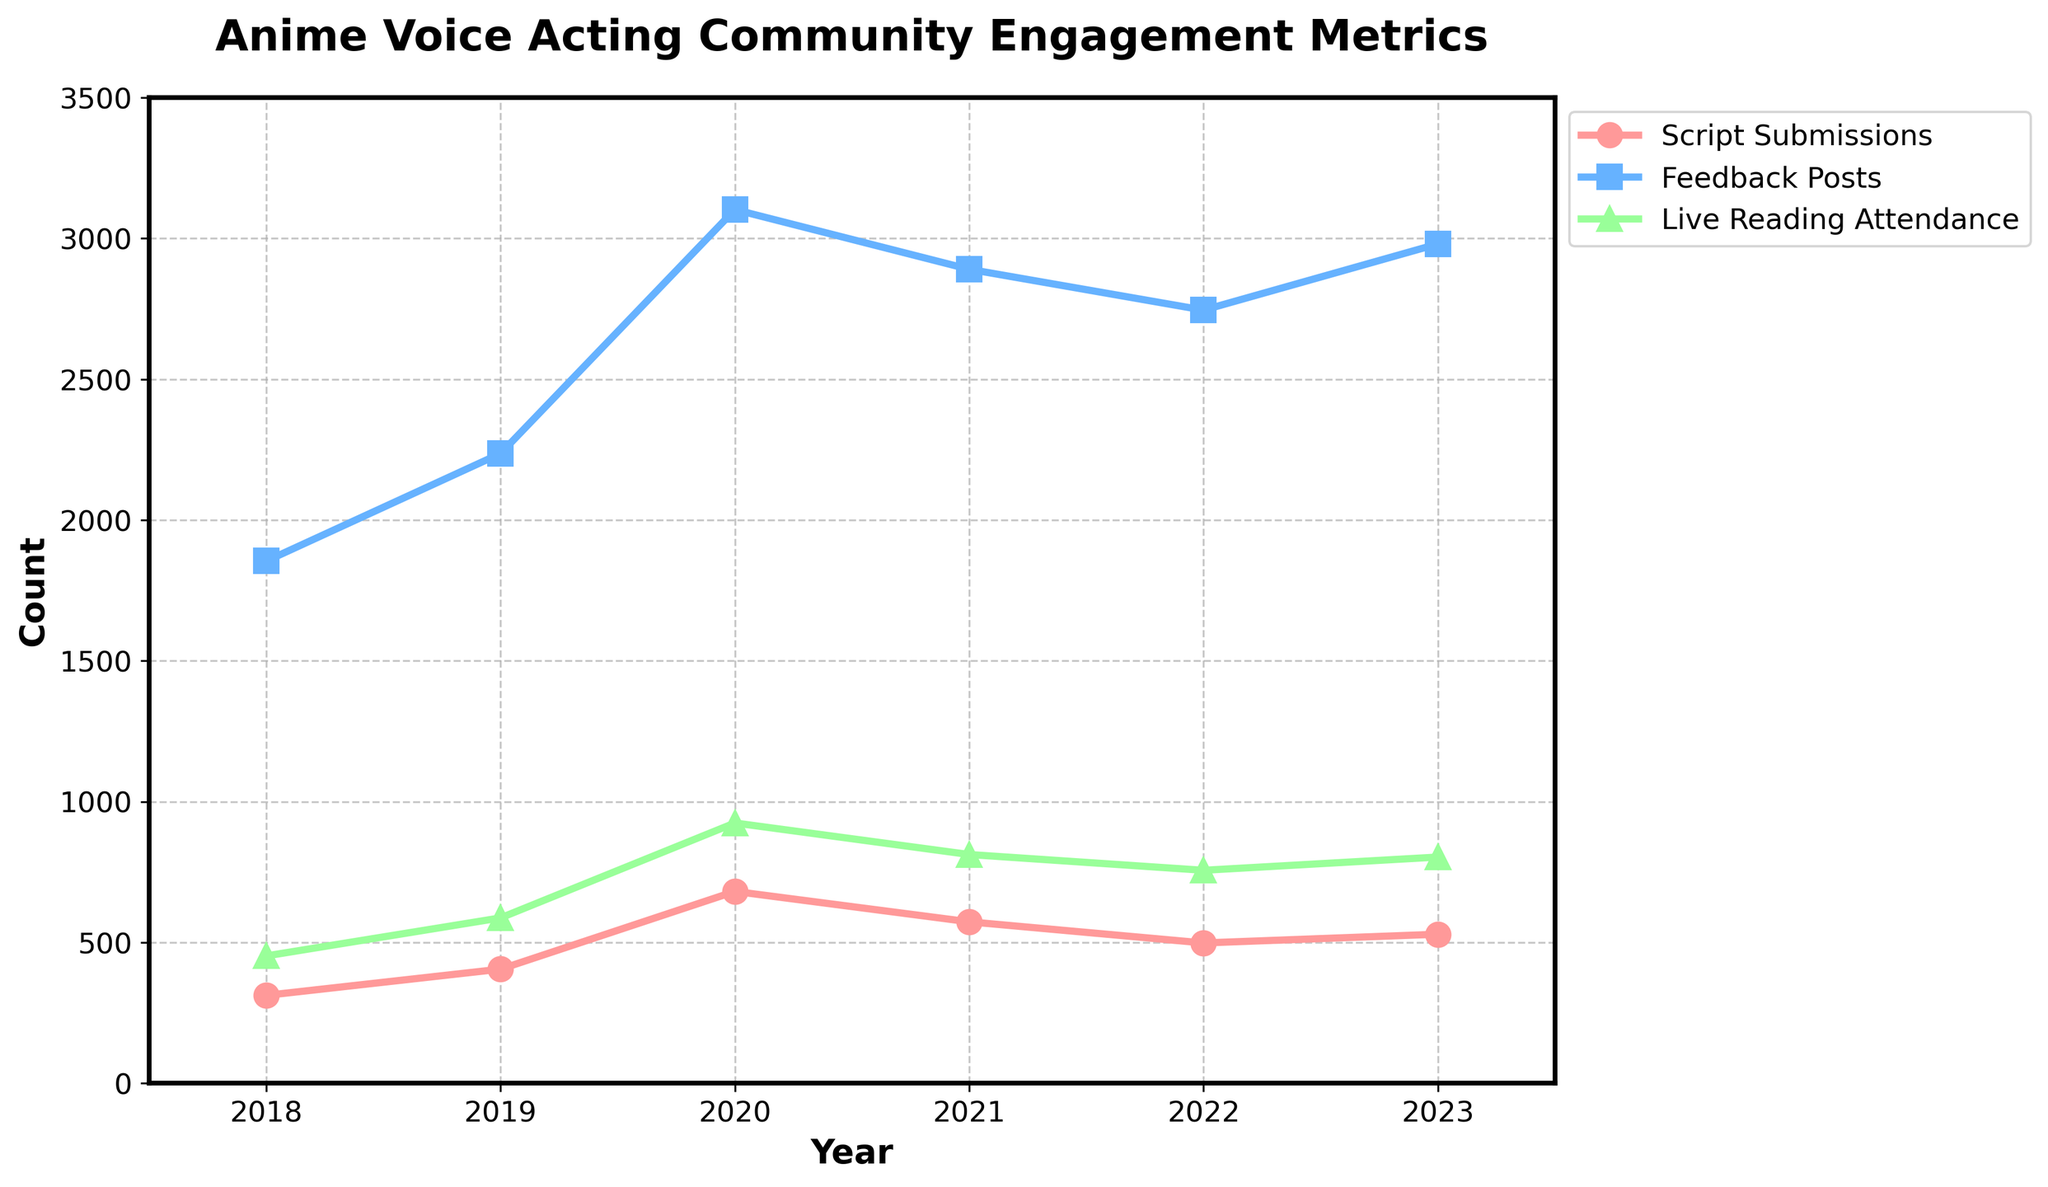Which year had the highest number of script submissions? To find the year with the highest number of script submissions, look at the peak point for the "Script Submissions" line (often displayed with a specific marker or color). In this chart, it's in 2020.
Answer: 2020 What is the average live reading attendance over the entire period? To calculate the average, sum all the yearly attendance numbers and divide by the number of years. Sum = 452 + 587 + 924 + 812 + 756 + 803 = 4334; Number of years = 6; Average = 4334 / 6 = 722.33
Answer: 722.33 How much did the number of feedback posts increase from 2018 to 2020? Subtract the number of feedback posts in 2018 from that in 2020. Difference = 3102 - 1854 = 1248
Answer: 1248 Between which two consecutive years did script submissions decrease the most? Look for the largest drop in the "Script Submissions" line by comparing the difference between each pair of consecutive years. The largest decrease occurs between 2020 (681) and 2021 (573). Decrease = 681 - 573 = 108
Answer: 2020 and 2021 How many total feedback posts were made from 2019 to 2021? Add the number of feedback posts made in 2019, 2020, and 2021. Total = 2236 + 3102 + 2890 = 8228
Answer: 8228 Which metric saw the largest increase from 2018 to 2019? Compare the increase in values for "Script Submissions," "Feedback Posts," and "Live Reading Attendance" from 2018 to 2019. Script Submissions: 405 - 312 = 93; Feedback Posts: 2236 - 1854 = 382; Live Reading Attendance: 587 - 452 = 135; Feedback Posts saw the largest increase.
Answer: Feedback Posts What is the total number of live reading attendees from 2018 to 2023 inclusive? Add the yearly attendance numbers from 2018 to 2023. Total = 452 + 587 + 924 + 812 + 756 + 803 = 4334
Answer: 4334 In which year did the feedback posts peak? Look for the highest point in the "Feedback Posts" line on the chart. The peak occurs in 2020.
Answer: 2020 How does the live reading attendance in 2021 compare to that in 2023? Compare the values in the chart for "Live Reading Attendance" in 2021 and 2023. 2021: 812, 2023: 803. The attendance in 2021 is slightly higher than in 2023.
Answer: 812 is higher than 803 